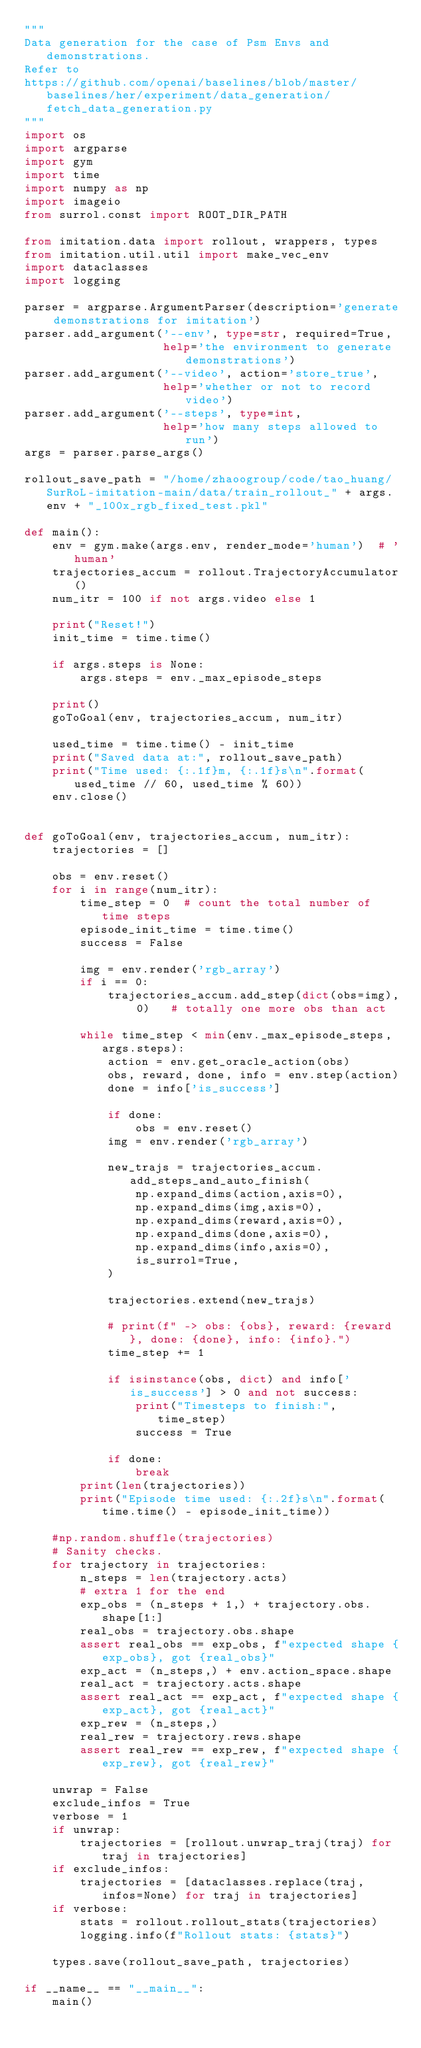Convert code to text. <code><loc_0><loc_0><loc_500><loc_500><_Python_>"""
Data generation for the case of Psm Envs and demonstrations.
Refer to
https://github.com/openai/baselines/blob/master/baselines/her/experiment/data_generation/fetch_data_generation.py
"""
import os
import argparse
import gym
import time
import numpy as np
import imageio
from surrol.const import ROOT_DIR_PATH

from imitation.data import rollout, wrappers, types
from imitation.util.util import make_vec_env
import dataclasses
import logging

parser = argparse.ArgumentParser(description='generate demonstrations for imitation')
parser.add_argument('--env', type=str, required=True,
                    help='the environment to generate demonstrations')
parser.add_argument('--video', action='store_true',
                    help='whether or not to record video')
parser.add_argument('--steps', type=int,
                    help='how many steps allowed to run')
args = parser.parse_args()

rollout_save_path = "/home/zhaoogroup/code/tao_huang/SurRoL-imitation-main/data/train_rollout_" + args.env + "_100x_rgb_fixed_test.pkl"

def main():
    env = gym.make(args.env, render_mode='human')  # 'human'     
    trajectories_accum = rollout.TrajectoryAccumulator()
    num_itr = 100 if not args.video else 1
    
    print("Reset!")
    init_time = time.time()

    if args.steps is None:
        args.steps = env._max_episode_steps

    print()
    goToGoal(env, trajectories_accum, num_itr)

    used_time = time.time() - init_time
    print("Saved data at:", rollout_save_path)
    print("Time used: {:.1f}m, {:.1f}s\n".format(used_time // 60, used_time % 60))
    env.close()


def goToGoal(env, trajectories_accum, num_itr):
    trajectories = []

    obs = env.reset()
    for i in range(num_itr):
        time_step = 0  # count the total number of time steps
        episode_init_time = time.time()
        success = False

        img = env.render('rgb_array')
        if i == 0:
            trajectories_accum.add_step(dict(obs=img), 0)   # totally one more obs than act

        while time_step < min(env._max_episode_steps, args.steps):
            action = env.get_oracle_action(obs)
            obs, reward, done, info = env.step(action)
            done = info['is_success']

            if done:
                obs = env.reset()
            img = env.render('rgb_array')
            
            new_trajs = trajectories_accum.add_steps_and_auto_finish(
                np.expand_dims(action,axis=0), 
                np.expand_dims(img,axis=0),
                np.expand_dims(reward,axis=0),
                np.expand_dims(done,axis=0), 
                np.expand_dims(info,axis=0),
                is_surrol=True,
            )

            trajectories.extend(new_trajs)
            
            # print(f" -> obs: {obs}, reward: {reward}, done: {done}, info: {info}.")
            time_step += 1

            if isinstance(obs, dict) and info['is_success'] > 0 and not success:
                print("Timesteps to finish:", time_step)
                success = True
            
            if done:
                break
        print(len(trajectories))
        print("Episode time used: {:.2f}s\n".format(time.time() - episode_init_time))

    #np.random.shuffle(trajectories)
    # Sanity checks.
    for trajectory in trajectories:
        n_steps = len(trajectory.acts)
        # extra 1 for the end
        exp_obs = (n_steps + 1,) + trajectory.obs.shape[1:]
        real_obs = trajectory.obs.shape
        assert real_obs == exp_obs, f"expected shape {exp_obs}, got {real_obs}"
        exp_act = (n_steps,) + env.action_space.shape
        real_act = trajectory.acts.shape
        assert real_act == exp_act, f"expected shape {exp_act}, got {real_act}"
        exp_rew = (n_steps,)
        real_rew = trajectory.rews.shape
        assert real_rew == exp_rew, f"expected shape {exp_rew}, got {real_rew}"

    unwrap = False
    exclude_infos = True
    verbose = 1
    if unwrap:
        trajectories = [rollout.unwrap_traj(traj) for traj in trajectories]
    if exclude_infos:
        trajectories = [dataclasses.replace(traj, infos=None) for traj in trajectories]
    if verbose:
        stats = rollout.rollout_stats(trajectories)
        logging.info(f"Rollout stats: {stats}")

    types.save(rollout_save_path, trajectories)

if __name__ == "__main__":
    main()
</code> 